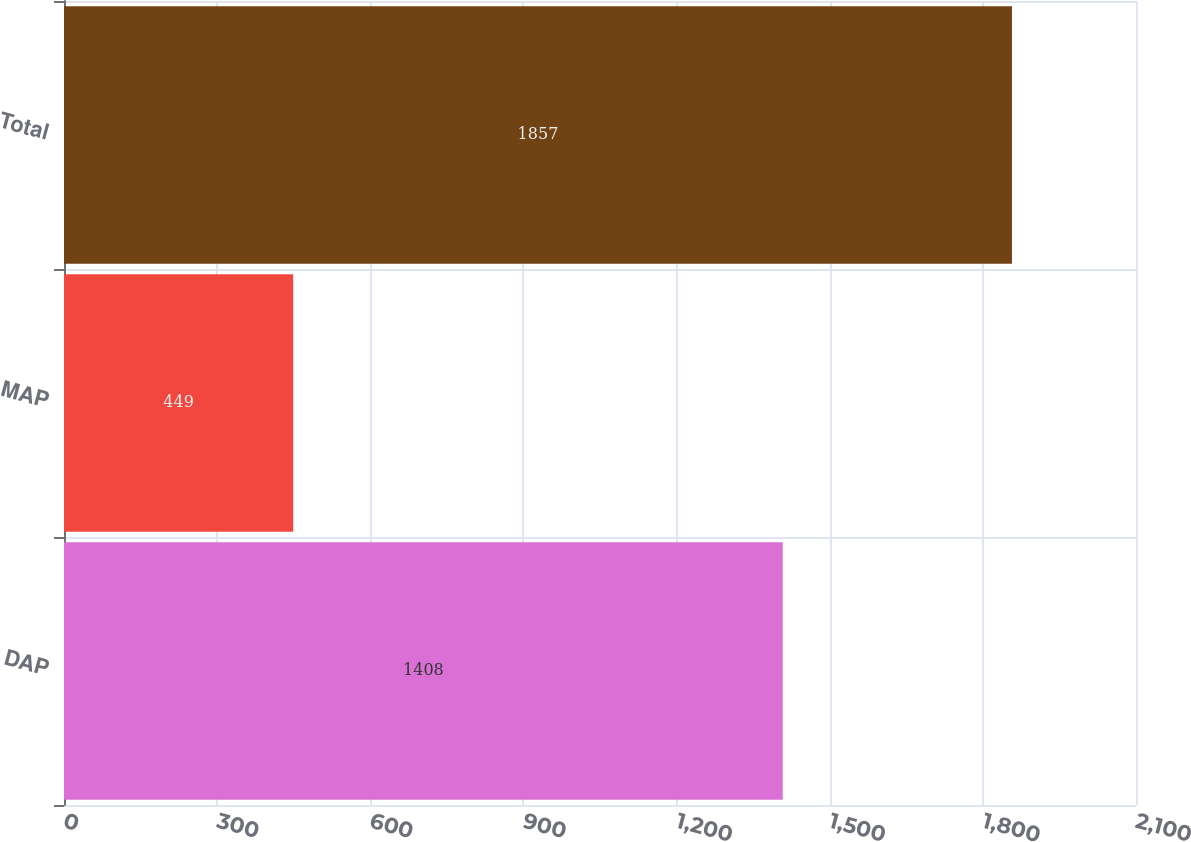<chart> <loc_0><loc_0><loc_500><loc_500><bar_chart><fcel>DAP<fcel>MAP<fcel>Total<nl><fcel>1408<fcel>449<fcel>1857<nl></chart> 